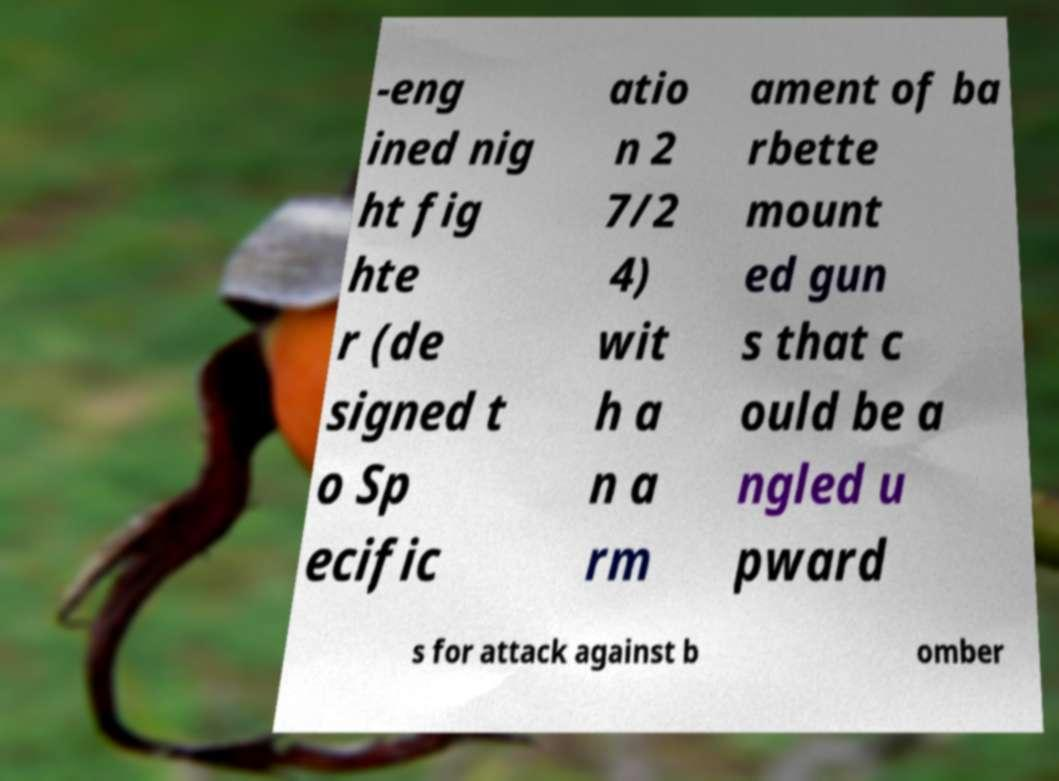Please identify and transcribe the text found in this image. -eng ined nig ht fig hte r (de signed t o Sp ecific atio n 2 7/2 4) wit h a n a rm ament of ba rbette mount ed gun s that c ould be a ngled u pward s for attack against b omber 